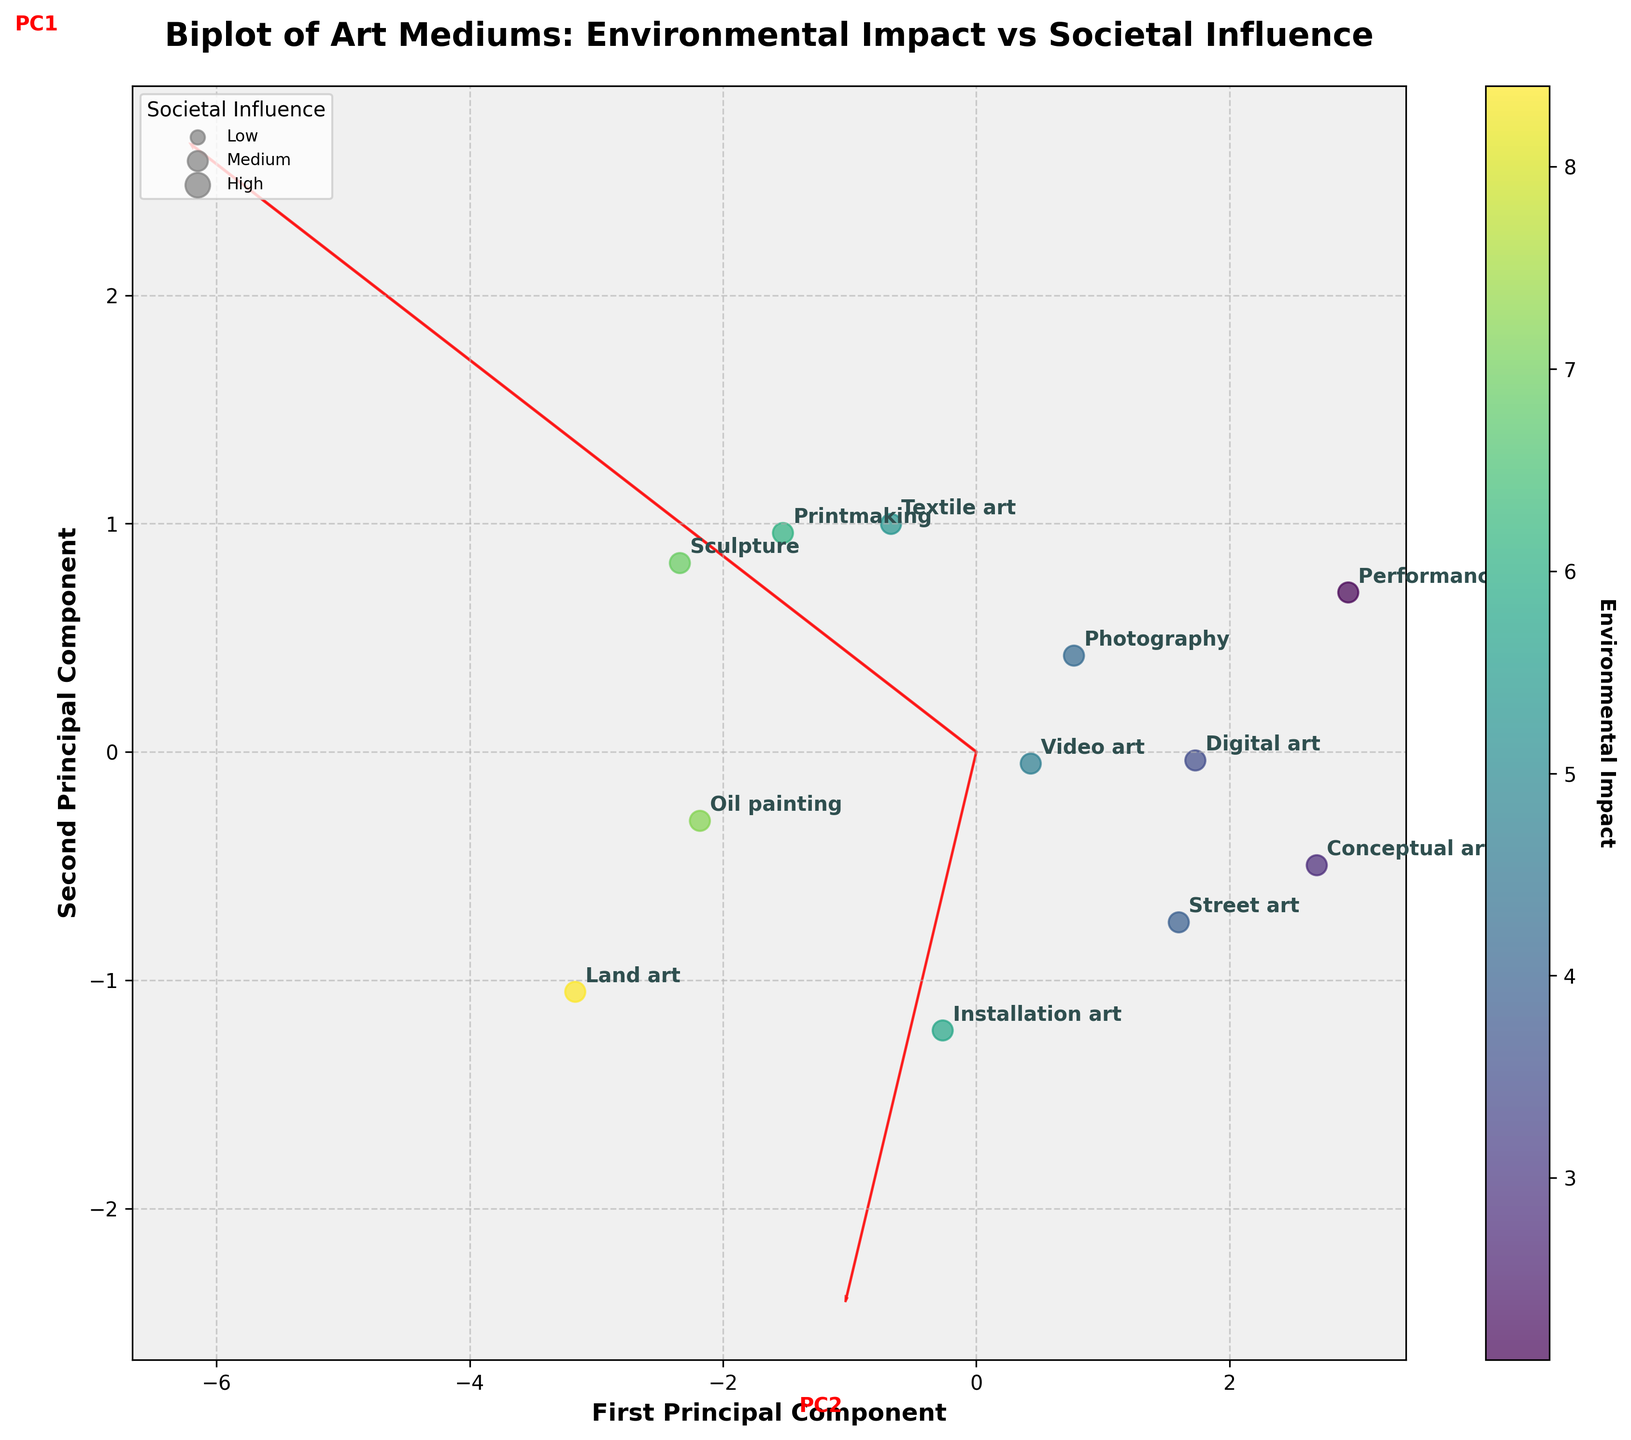What is the title of the figure? The title is displayed at the top center of the figure.
Answer: Biplot of Art Mediums: Environmental Impact vs Societal Influence How is the color gradient in the scatter plot defined? The color gradient shown in the figure (ranging from light to dark shades) represents the Environmental Impact of each art medium, as indicated by the color bar.
Answer: It represents Environmental Impact Which art medium has the highest societal influence? By looking at the y-axis, you can see the points plotted at higher values, and Conceptual art is annotated at the highest societal influence value.
Answer: Conceptual art How are the axes labeled? The labels are found on the x-axis and y-axis of the plot.
Answer: First Principal Component (x-axis), Second Principal Component (y-axis) Which art mediums have a higher environmental impact than a societal influence? By observing the points where the x-axis value (Environmental Impact) is greater than the y-axis value (Societal Influence), we see Oil painting and Printmaking as those media.
Answer: Oil painting, Printmaking Which art medium has the lowest environmental impact and how is it represented in the plot? By inspecting the spread of points along the color gradient and identifying the lightest shade, Performance art, located at the lower end on the Environmental Impact axis, represents this.
Answer: Performance art How are the principal component axes highlighted in the plot? The principal components are displayed using arrows emerging from the origin, with text labels PC1 and PC2 at the ends of the arrows.
Answer: With red arrows and text labels (PC1, PC2) What does the size of the scatter points signify in the figure? By the plot legend, the scatter points' sizes indicate the degree of Societal Influence for each medium, divided into low, medium, and high categories.
Answer: Societal Influence Which art medium has a high environmental impact but a medium societal influence? By locating the points on the plot where the environmental impact is high (darker shade) and societal influence is medium (medium-sized scatter), we can identify Land art.
Answer: Land art 